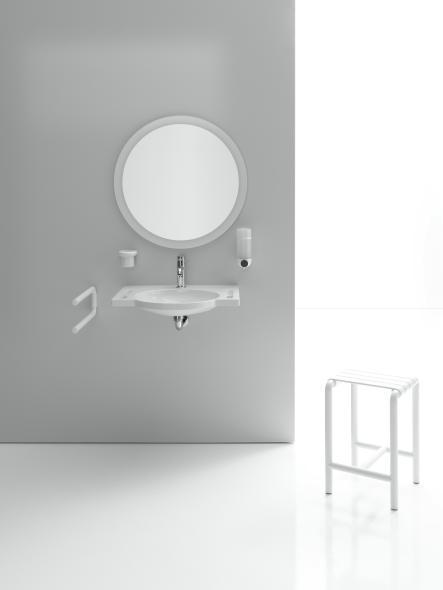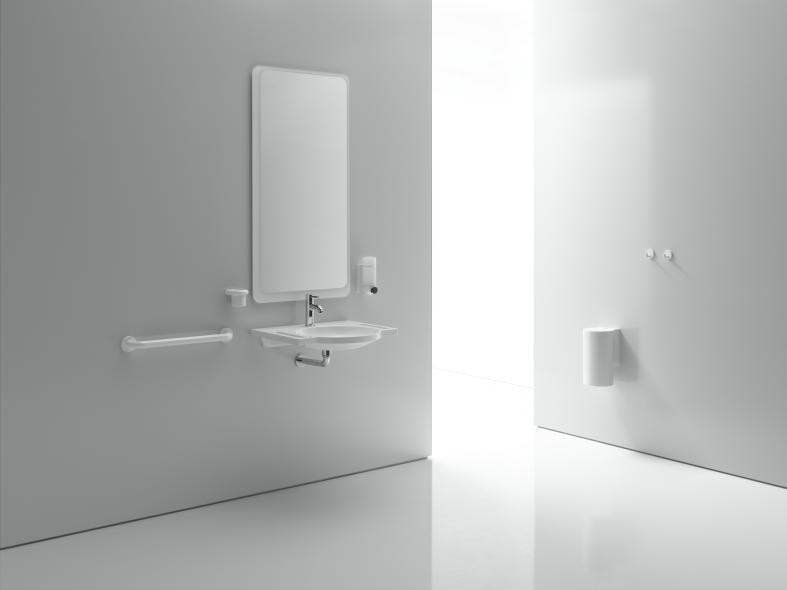The first image is the image on the left, the second image is the image on the right. For the images shown, is this caption "All sinks shown mount to the wall and have a rounded inset basin without a separate counter." true? Answer yes or no. Yes. The first image is the image on the left, the second image is the image on the right. Considering the images on both sides, is "A rectangular mirror hangs over  a wash basin in one of the images." valid? Answer yes or no. Yes. 